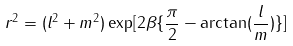Convert formula to latex. <formula><loc_0><loc_0><loc_500><loc_500>r ^ { 2 } = ( l ^ { 2 } + m ^ { 2 } ) \exp [ 2 \beta \{ \frac { \pi } { 2 } - \arctan ( \frac { l } { m } ) \} ]</formula> 